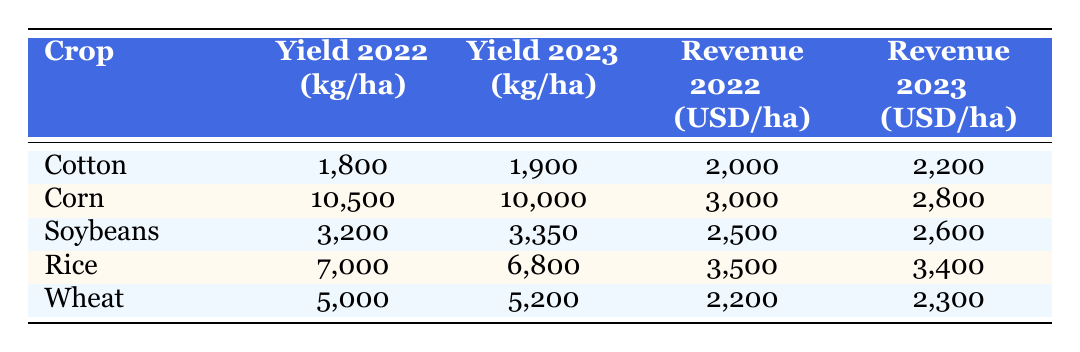What was the yield of cotton in 2022? The table shows the yield for cotton in 2022 is listed under the "Yield 2022 (kg/ha)" column. It states that the yield was 1800 kg per hectare.
Answer: 1800 kg/ha What is the revenue per hectare for soybeans in 2023? The revenue for soybeans in 2023 can be found in the "Revenue 2023 (USD/ha)" column. The table indicates that the revenue is 2600 USD per hectare.
Answer: 2600 USD/ha Did the corn yield increase from 2022 to 2023? By comparing the "Yield 2022 (kg/ha)" and "Yield 2023 (kg/ha)" columns for corn, we see that the yield was 10500 kg/ha in 2022 and decreased to 10000 kg/ha in 2023. Therefore, the yield did not increase.
Answer: No What is the difference in revenue between cotton in 2023 and revenue for corn in 2022? First, we find the revenue for cotton in 2023 from the "Revenue 2023 (USD/ha)" column, which is 2200 USD/ha. Next, we find the revenue for corn in 2022 from the "Revenue 2022 (USD/ha)" column, which is 3000 USD/ha. Then, we calculate the difference: 2200 - 3000 = -800 USD/ha.
Answer: -800 USD/ha What was the average yield of all crops in 2023? To find the average yield in 2023, we first add the yields for all crops listed: Cotton (1900) + Corn (10000) + Soybeans (3350) + Rice (6800) + Wheat (5200) = 23450 kg/ha. We then divide this sum by the number of crops, which is 5: 23450 / 5 = 4690 kg/ha.
Answer: 4690 kg/ha Was the revenue for rice higher in 2022 or 2023? We compare the revenue for rice in both years. The table shows that the revenue for rice in 2022 was 3500 USD/ha and for 2023 it was 3400 USD/ha. The revenue was higher in 2022.
Answer: Yes What is the total yield of all crops in 2022? We add the yields for all crops listed in 2022: Cotton (1800) + Corn (10500) + Soybeans (3200) + Rice (7000) + Wheat (5000) = 28800 kg/ha. Thus, the total yield for all crops in 2022 is 28800 kg/ha.
Answer: 28800 kg/ha Which crop had the highest revenue in 2022? To determine this, we compare the revenue for all crops in 2022 as listed in the "Revenue 2022 (USD/ha)" column. The revenue values are: Cotton (2000), Corn (3000), Soybeans (2500), Rice (3500), Wheat (2200). The highest revenue is for Rice at 3500 USD/ha.
Answer: Rice What was the percentage change in revenue for wheat from 2022 to 2023? First, we find the revenue for wheat in 2022 from the table, which is 2200 USD/ha and in 2023 it is 2300 USD/ha. The change in revenue is 2300 - 2200 = 100 USD/ha. To find the percentage change, we divide the change by the original amount and multiply by 100: (100 / 2200) * 100 = 4.545% (approximately 4.55%).
Answer: 4.55% 